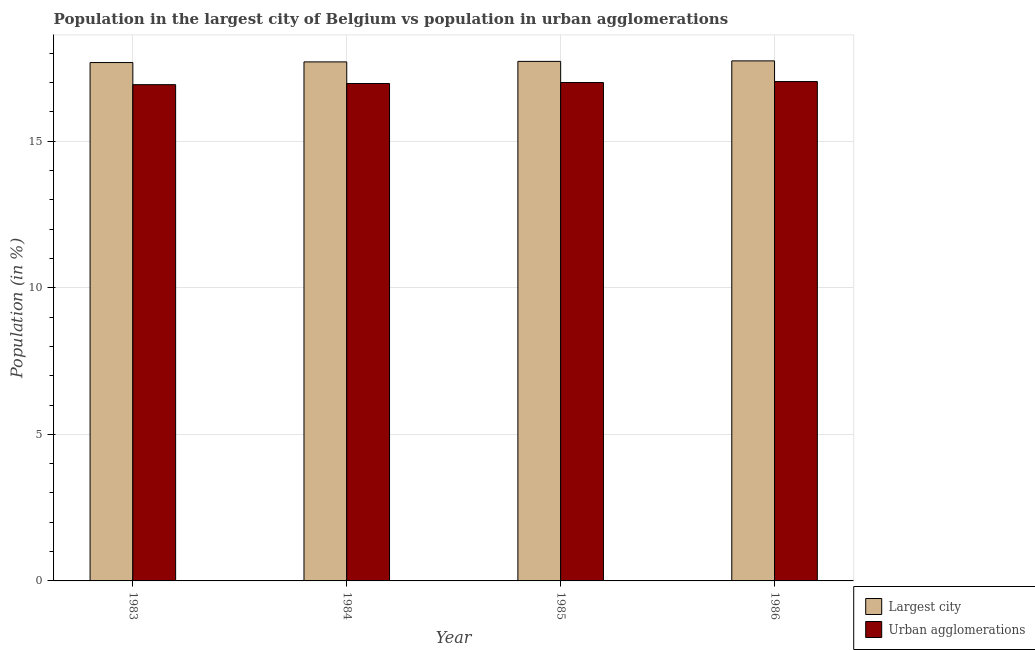How many groups of bars are there?
Provide a succinct answer. 4. How many bars are there on the 3rd tick from the right?
Give a very brief answer. 2. In how many cases, is the number of bars for a given year not equal to the number of legend labels?
Your response must be concise. 0. What is the population in the largest city in 1983?
Offer a very short reply. 17.68. Across all years, what is the maximum population in the largest city?
Provide a succinct answer. 17.74. Across all years, what is the minimum population in the largest city?
Your response must be concise. 17.68. What is the total population in the largest city in the graph?
Provide a short and direct response. 70.86. What is the difference between the population in urban agglomerations in 1984 and that in 1986?
Give a very brief answer. -0.07. What is the difference between the population in the largest city in 1986 and the population in urban agglomerations in 1984?
Offer a very short reply. 0.03. What is the average population in urban agglomerations per year?
Make the answer very short. 16.98. In how many years, is the population in urban agglomerations greater than 17 %?
Your response must be concise. 2. What is the ratio of the population in the largest city in 1983 to that in 1985?
Give a very brief answer. 1. What is the difference between the highest and the second highest population in the largest city?
Offer a very short reply. 0.02. What is the difference between the highest and the lowest population in the largest city?
Provide a short and direct response. 0.06. In how many years, is the population in urban agglomerations greater than the average population in urban agglomerations taken over all years?
Offer a very short reply. 2. Is the sum of the population in urban agglomerations in 1983 and 1986 greater than the maximum population in the largest city across all years?
Your answer should be compact. Yes. What does the 1st bar from the left in 1983 represents?
Offer a terse response. Largest city. What does the 2nd bar from the right in 1983 represents?
Offer a terse response. Largest city. Are all the bars in the graph horizontal?
Your answer should be compact. No. What is the difference between two consecutive major ticks on the Y-axis?
Ensure brevity in your answer.  5. How many legend labels are there?
Provide a succinct answer. 2. What is the title of the graph?
Your response must be concise. Population in the largest city of Belgium vs population in urban agglomerations. Does "Grants" appear as one of the legend labels in the graph?
Ensure brevity in your answer.  No. What is the label or title of the X-axis?
Your answer should be compact. Year. What is the label or title of the Y-axis?
Keep it short and to the point. Population (in %). What is the Population (in %) in Largest city in 1983?
Your response must be concise. 17.68. What is the Population (in %) of Urban agglomerations in 1983?
Provide a succinct answer. 16.93. What is the Population (in %) in Largest city in 1984?
Make the answer very short. 17.71. What is the Population (in %) in Urban agglomerations in 1984?
Ensure brevity in your answer.  16.97. What is the Population (in %) in Largest city in 1985?
Make the answer very short. 17.72. What is the Population (in %) of Urban agglomerations in 1985?
Give a very brief answer. 17. What is the Population (in %) of Largest city in 1986?
Keep it short and to the point. 17.74. What is the Population (in %) in Urban agglomerations in 1986?
Offer a terse response. 17.04. Across all years, what is the maximum Population (in %) of Largest city?
Offer a terse response. 17.74. Across all years, what is the maximum Population (in %) of Urban agglomerations?
Ensure brevity in your answer.  17.04. Across all years, what is the minimum Population (in %) in Largest city?
Provide a succinct answer. 17.68. Across all years, what is the minimum Population (in %) of Urban agglomerations?
Your response must be concise. 16.93. What is the total Population (in %) in Largest city in the graph?
Offer a terse response. 70.86. What is the total Population (in %) of Urban agglomerations in the graph?
Give a very brief answer. 67.94. What is the difference between the Population (in %) of Largest city in 1983 and that in 1984?
Your response must be concise. -0.02. What is the difference between the Population (in %) in Urban agglomerations in 1983 and that in 1984?
Your answer should be very brief. -0.04. What is the difference between the Population (in %) in Largest city in 1983 and that in 1985?
Make the answer very short. -0.04. What is the difference between the Population (in %) of Urban agglomerations in 1983 and that in 1985?
Your answer should be very brief. -0.07. What is the difference between the Population (in %) in Largest city in 1983 and that in 1986?
Make the answer very short. -0.06. What is the difference between the Population (in %) in Urban agglomerations in 1983 and that in 1986?
Offer a very short reply. -0.11. What is the difference between the Population (in %) of Largest city in 1984 and that in 1985?
Provide a succinct answer. -0.02. What is the difference between the Population (in %) in Urban agglomerations in 1984 and that in 1985?
Your answer should be compact. -0.03. What is the difference between the Population (in %) in Largest city in 1984 and that in 1986?
Your answer should be very brief. -0.03. What is the difference between the Population (in %) of Urban agglomerations in 1984 and that in 1986?
Offer a terse response. -0.07. What is the difference between the Population (in %) of Largest city in 1985 and that in 1986?
Provide a succinct answer. -0.02. What is the difference between the Population (in %) in Urban agglomerations in 1985 and that in 1986?
Ensure brevity in your answer.  -0.03. What is the difference between the Population (in %) of Largest city in 1983 and the Population (in %) of Urban agglomerations in 1984?
Provide a succinct answer. 0.71. What is the difference between the Population (in %) of Largest city in 1983 and the Population (in %) of Urban agglomerations in 1985?
Offer a terse response. 0.68. What is the difference between the Population (in %) in Largest city in 1983 and the Population (in %) in Urban agglomerations in 1986?
Make the answer very short. 0.65. What is the difference between the Population (in %) of Largest city in 1984 and the Population (in %) of Urban agglomerations in 1985?
Provide a short and direct response. 0.7. What is the difference between the Population (in %) in Largest city in 1984 and the Population (in %) in Urban agglomerations in 1986?
Keep it short and to the point. 0.67. What is the difference between the Population (in %) of Largest city in 1985 and the Population (in %) of Urban agglomerations in 1986?
Your answer should be very brief. 0.69. What is the average Population (in %) of Largest city per year?
Your answer should be very brief. 17.71. What is the average Population (in %) in Urban agglomerations per year?
Your answer should be very brief. 16.98. In the year 1983, what is the difference between the Population (in %) of Largest city and Population (in %) of Urban agglomerations?
Your response must be concise. 0.75. In the year 1984, what is the difference between the Population (in %) in Largest city and Population (in %) in Urban agglomerations?
Your answer should be very brief. 0.74. In the year 1985, what is the difference between the Population (in %) in Largest city and Population (in %) in Urban agglomerations?
Your answer should be very brief. 0.72. In the year 1986, what is the difference between the Population (in %) of Largest city and Population (in %) of Urban agglomerations?
Ensure brevity in your answer.  0.71. What is the ratio of the Population (in %) of Largest city in 1983 to that in 1984?
Your answer should be very brief. 1. What is the ratio of the Population (in %) in Urban agglomerations in 1983 to that in 1984?
Make the answer very short. 1. What is the ratio of the Population (in %) in Urban agglomerations in 1983 to that in 1985?
Give a very brief answer. 1. What is the ratio of the Population (in %) of Largest city in 1984 to that in 1986?
Your response must be concise. 1. What is the ratio of the Population (in %) in Largest city in 1985 to that in 1986?
Keep it short and to the point. 1. What is the ratio of the Population (in %) in Urban agglomerations in 1985 to that in 1986?
Ensure brevity in your answer.  1. What is the difference between the highest and the second highest Population (in %) of Largest city?
Keep it short and to the point. 0.02. What is the difference between the highest and the second highest Population (in %) in Urban agglomerations?
Ensure brevity in your answer.  0.03. What is the difference between the highest and the lowest Population (in %) in Largest city?
Your answer should be compact. 0.06. What is the difference between the highest and the lowest Population (in %) in Urban agglomerations?
Your answer should be very brief. 0.11. 